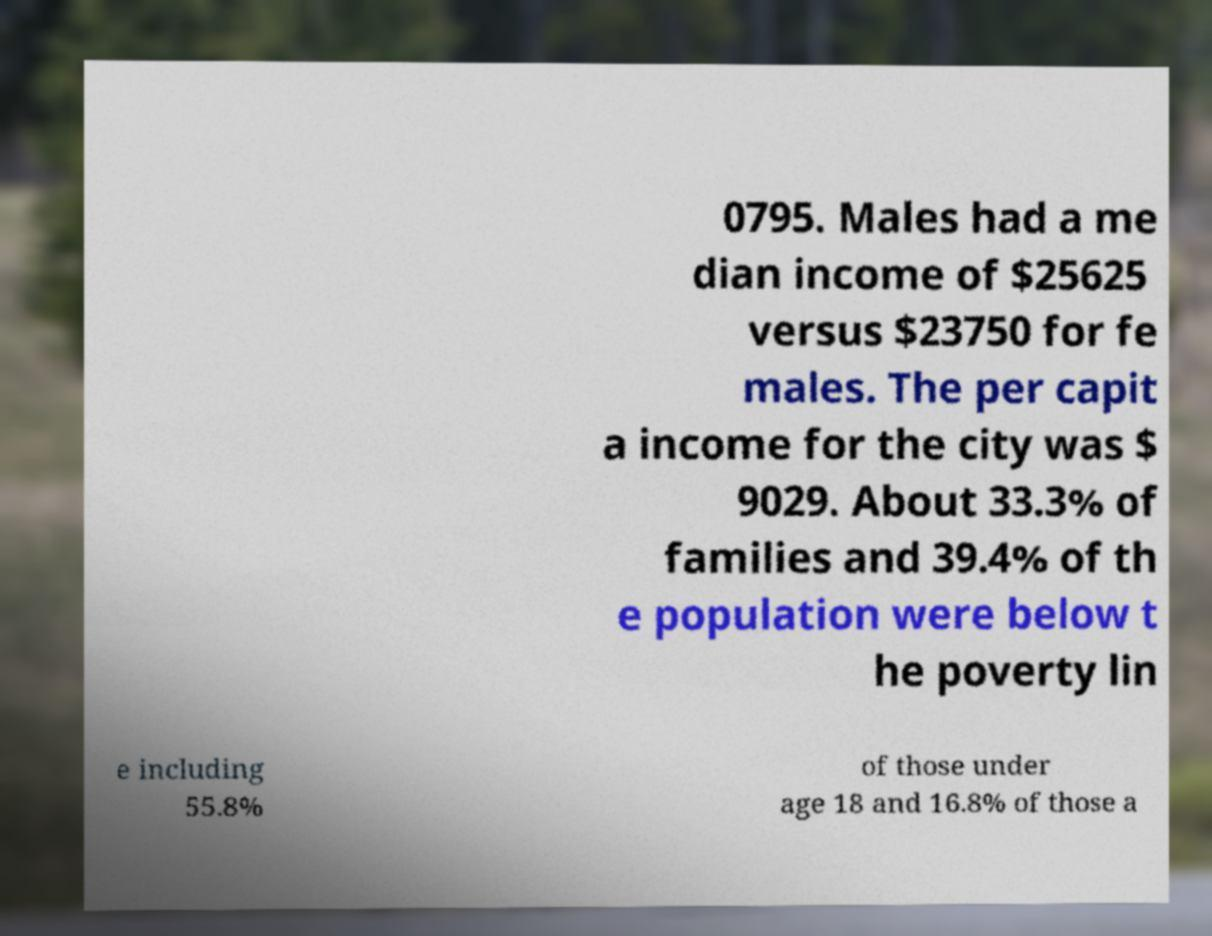Can you read and provide the text displayed in the image?This photo seems to have some interesting text. Can you extract and type it out for me? 0795. Males had a me dian income of $25625 versus $23750 for fe males. The per capit a income for the city was $ 9029. About 33.3% of families and 39.4% of th e population were below t he poverty lin e including 55.8% of those under age 18 and 16.8% of those a 